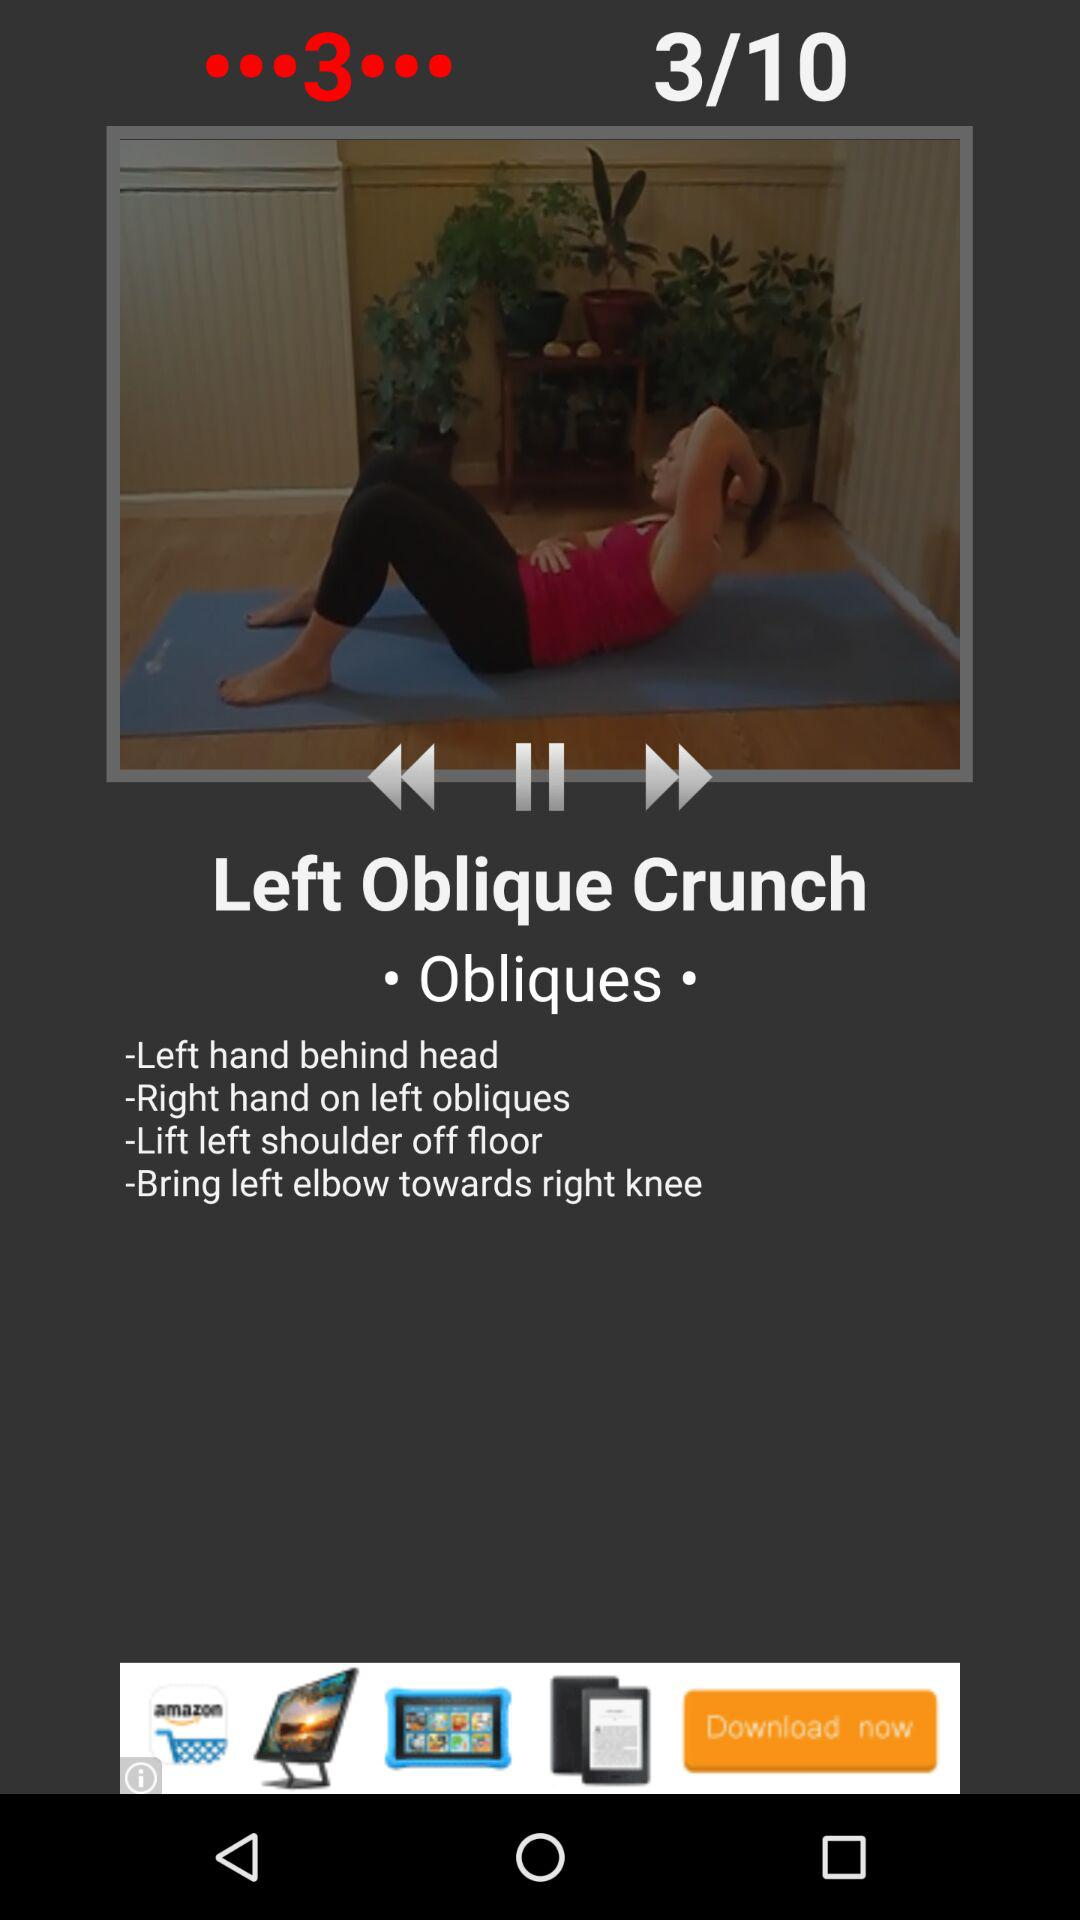How many steps do the instructions have?
Answer the question using a single word or phrase. 4 